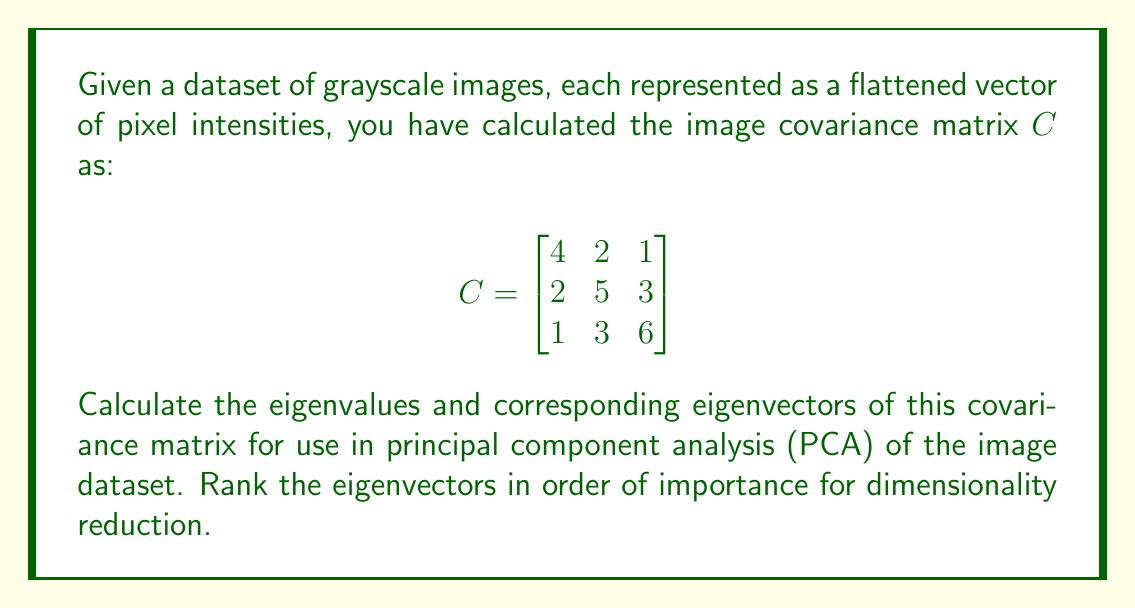Provide a solution to this math problem. To find the eigenvalues and eigenvectors of the covariance matrix $C$, we follow these steps:

1) First, we calculate the characteristic equation:
   $det(C - \lambda I) = 0$

   $$\begin{vmatrix}
   4-\lambda & 2 & 1 \\
   2 & 5-\lambda & 3 \\
   1 & 3 & 6-\lambda
   \end{vmatrix} = 0$$

2) Expanding the determinant:
   $(4-\lambda)[(5-\lambda)(6-\lambda)-9] - 2[2(6-\lambda)-3] + 1[6-3(5-\lambda)] = 0$
   
   $-\lambda^3 + 15\lambda^2 - 71\lambda + 105 = 0$

3) Solving this cubic equation (using a computer algebra system or numerical methods), we get the eigenvalues:
   $\lambda_1 \approx 9.47$
   $\lambda_2 \approx 3.73$
   $\lambda_3 \approx 1.80$

4) For each eigenvalue, we solve $(C - \lambda_i I)v_i = 0$ to find the corresponding eigenvector:

   For $\lambda_1 \approx 9.47$:
   $$\begin{bmatrix}
   -5.47 & 2 & 1 \\
   2 & -4.47 & 3 \\
   1 & 3 & -3.47
   \end{bmatrix} \begin{bmatrix} v_1 \\ v_2 \\ v_3 \end{bmatrix} = \begin{bmatrix} 0 \\ 0 \\ 0 \end{bmatrix}$$

   Solving this system gives us (after normalization):
   $v_1 \approx [0.418, 0.606, 0.677]^T$

   Similarly, for $\lambda_2$ and $\lambda_3$, we get:
   $v_2 \approx [-0.866, 0.131, 0.482]^T$
   $v_3 \approx [0.275, -0.785, 0.556]^T$

5) In PCA, the eigenvectors are ranked by their corresponding eigenvalues. The larger the eigenvalue, the more important the eigenvector for capturing variance in the dataset.

Therefore, the ranking of importance is: $v_1$, $v_2$, $v_3$.
Answer: Eigenvalues: $\lambda_1 \approx 9.47$, $\lambda_2 \approx 3.73$, $\lambda_3 \approx 1.80$

Eigenvectors (normalized):
$v_1 \approx [0.418, 0.606, 0.677]^T$
$v_2 \approx [-0.866, 0.131, 0.482]^T$
$v_3 \approx [0.275, -0.785, 0.556]^T$

Ranked in order of importance: $v_1$, $v_2$, $v_3$ 